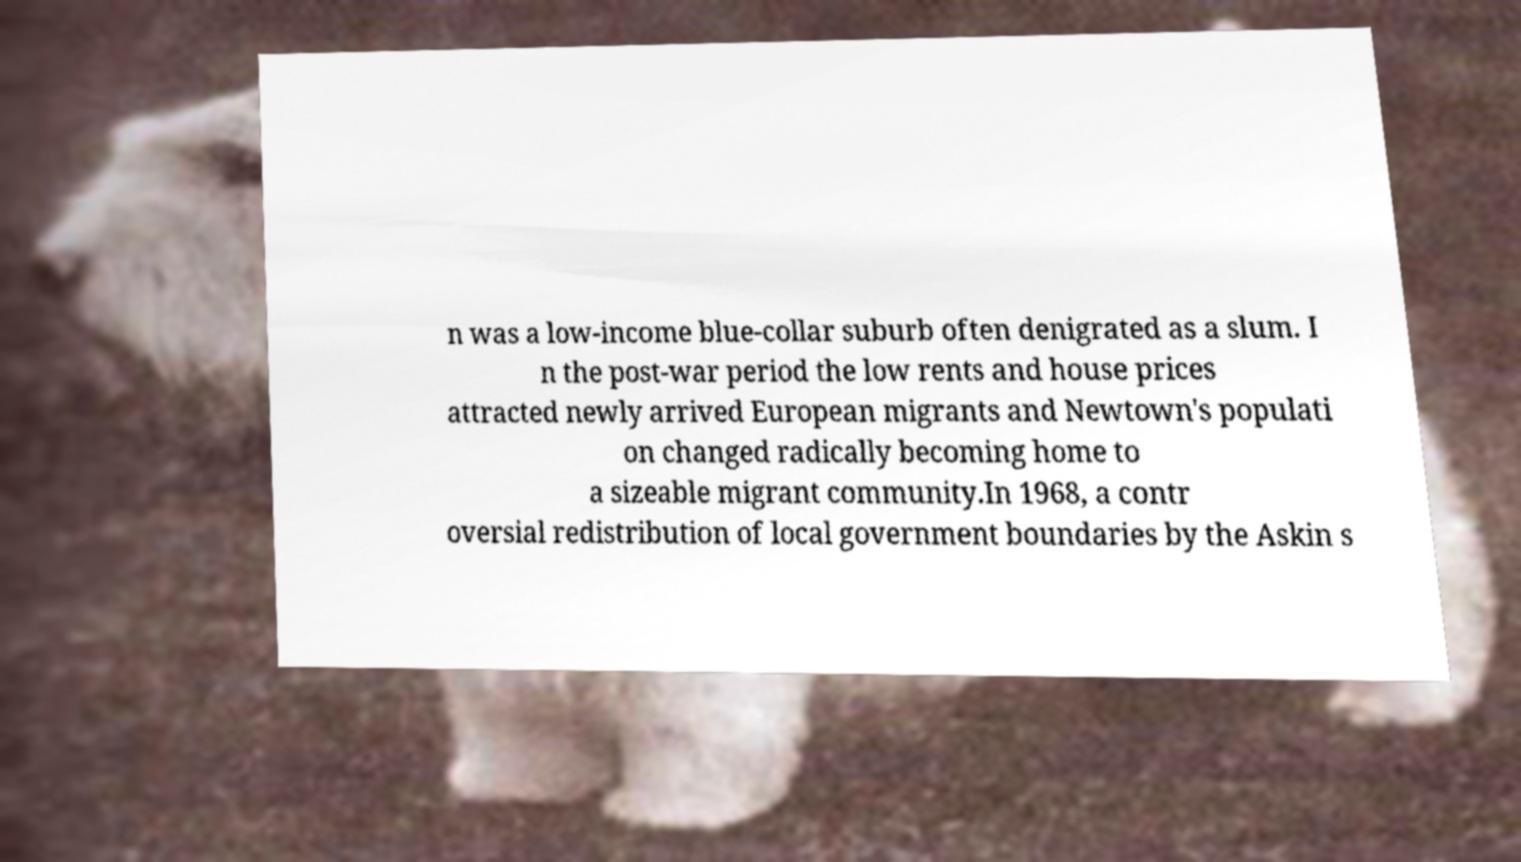Can you read and provide the text displayed in the image?This photo seems to have some interesting text. Can you extract and type it out for me? n was a low-income blue-collar suburb often denigrated as a slum. I n the post-war period the low rents and house prices attracted newly arrived European migrants and Newtown's populati on changed radically becoming home to a sizeable migrant community.In 1968, a contr oversial redistribution of local government boundaries by the Askin s 